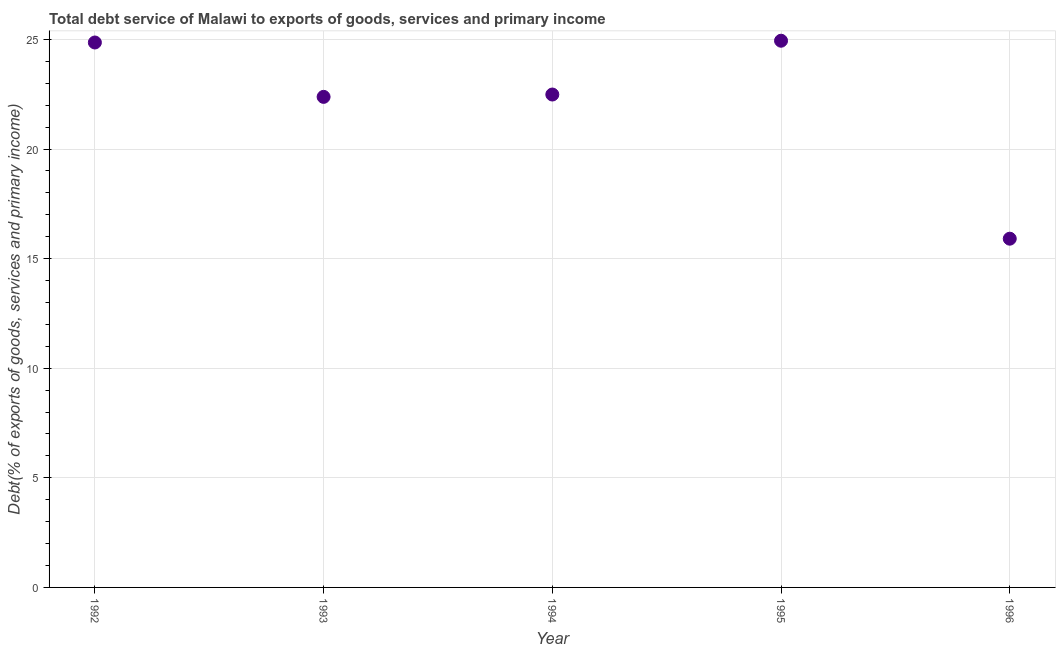What is the total debt service in 1996?
Your answer should be compact. 15.91. Across all years, what is the maximum total debt service?
Offer a terse response. 24.94. Across all years, what is the minimum total debt service?
Ensure brevity in your answer.  15.91. In which year was the total debt service minimum?
Your response must be concise. 1996. What is the sum of the total debt service?
Offer a terse response. 110.57. What is the difference between the total debt service in 1992 and 1993?
Ensure brevity in your answer.  2.48. What is the average total debt service per year?
Your response must be concise. 22.11. What is the median total debt service?
Ensure brevity in your answer.  22.49. What is the ratio of the total debt service in 1993 to that in 1994?
Provide a short and direct response. 1. Is the total debt service in 1992 less than that in 1996?
Offer a terse response. No. Is the difference between the total debt service in 1995 and 1996 greater than the difference between any two years?
Provide a succinct answer. Yes. What is the difference between the highest and the second highest total debt service?
Your response must be concise. 0.08. Is the sum of the total debt service in 1993 and 1994 greater than the maximum total debt service across all years?
Make the answer very short. Yes. What is the difference between the highest and the lowest total debt service?
Your answer should be very brief. 9.03. In how many years, is the total debt service greater than the average total debt service taken over all years?
Offer a very short reply. 4. Does the total debt service monotonically increase over the years?
Your answer should be very brief. No. Does the graph contain grids?
Your response must be concise. Yes. What is the title of the graph?
Give a very brief answer. Total debt service of Malawi to exports of goods, services and primary income. What is the label or title of the Y-axis?
Give a very brief answer. Debt(% of exports of goods, services and primary income). What is the Debt(% of exports of goods, services and primary income) in 1992?
Ensure brevity in your answer.  24.86. What is the Debt(% of exports of goods, services and primary income) in 1993?
Provide a succinct answer. 22.38. What is the Debt(% of exports of goods, services and primary income) in 1994?
Your answer should be very brief. 22.49. What is the Debt(% of exports of goods, services and primary income) in 1995?
Provide a short and direct response. 24.94. What is the Debt(% of exports of goods, services and primary income) in 1996?
Give a very brief answer. 15.91. What is the difference between the Debt(% of exports of goods, services and primary income) in 1992 and 1993?
Offer a very short reply. 2.48. What is the difference between the Debt(% of exports of goods, services and primary income) in 1992 and 1994?
Ensure brevity in your answer.  2.37. What is the difference between the Debt(% of exports of goods, services and primary income) in 1992 and 1995?
Keep it short and to the point. -0.08. What is the difference between the Debt(% of exports of goods, services and primary income) in 1992 and 1996?
Make the answer very short. 8.95. What is the difference between the Debt(% of exports of goods, services and primary income) in 1993 and 1994?
Your response must be concise. -0.11. What is the difference between the Debt(% of exports of goods, services and primary income) in 1993 and 1995?
Your answer should be compact. -2.56. What is the difference between the Debt(% of exports of goods, services and primary income) in 1993 and 1996?
Give a very brief answer. 6.47. What is the difference between the Debt(% of exports of goods, services and primary income) in 1994 and 1995?
Give a very brief answer. -2.45. What is the difference between the Debt(% of exports of goods, services and primary income) in 1994 and 1996?
Provide a short and direct response. 6.58. What is the difference between the Debt(% of exports of goods, services and primary income) in 1995 and 1996?
Give a very brief answer. 9.03. What is the ratio of the Debt(% of exports of goods, services and primary income) in 1992 to that in 1993?
Your response must be concise. 1.11. What is the ratio of the Debt(% of exports of goods, services and primary income) in 1992 to that in 1994?
Make the answer very short. 1.11. What is the ratio of the Debt(% of exports of goods, services and primary income) in 1992 to that in 1996?
Ensure brevity in your answer.  1.56. What is the ratio of the Debt(% of exports of goods, services and primary income) in 1993 to that in 1994?
Offer a terse response. 0.99. What is the ratio of the Debt(% of exports of goods, services and primary income) in 1993 to that in 1995?
Your answer should be very brief. 0.9. What is the ratio of the Debt(% of exports of goods, services and primary income) in 1993 to that in 1996?
Offer a very short reply. 1.41. What is the ratio of the Debt(% of exports of goods, services and primary income) in 1994 to that in 1995?
Your answer should be very brief. 0.9. What is the ratio of the Debt(% of exports of goods, services and primary income) in 1994 to that in 1996?
Keep it short and to the point. 1.41. What is the ratio of the Debt(% of exports of goods, services and primary income) in 1995 to that in 1996?
Offer a terse response. 1.57. 